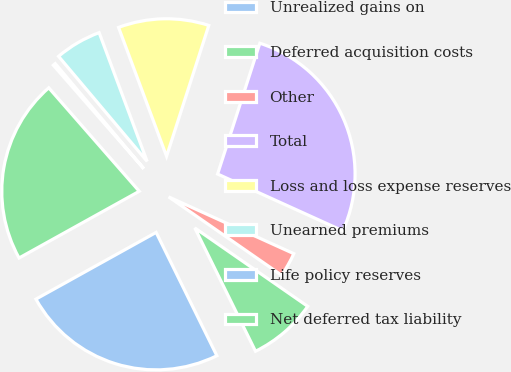Convert chart to OTSL. <chart><loc_0><loc_0><loc_500><loc_500><pie_chart><fcel>Unrealized gains on<fcel>Deferred acquisition costs<fcel>Other<fcel>Total<fcel>Loss and loss expense reserves<fcel>Unearned premiums<fcel>Life policy reserves<fcel>Net deferred tax liability<nl><fcel>24.22%<fcel>8.06%<fcel>2.88%<fcel>26.81%<fcel>10.65%<fcel>5.47%<fcel>0.29%<fcel>21.63%<nl></chart> 